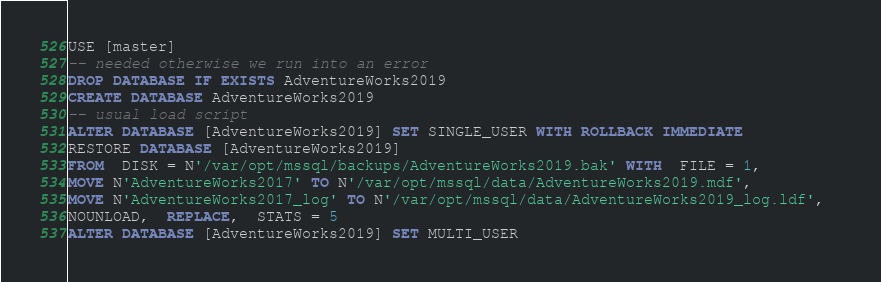Convert code to text. <code><loc_0><loc_0><loc_500><loc_500><_SQL_>USE [master]
-- needed otherwise we run into an error
DROP DATABASE IF EXISTS AdventureWorks2019
CREATE DATABASE AdventureWorks2019
-- usual load script
ALTER DATABASE [AdventureWorks2019] SET SINGLE_USER WITH ROLLBACK IMMEDIATE
RESTORE DATABASE [AdventureWorks2019] 
FROM  DISK = N'/var/opt/mssql/backups/AdventureWorks2019.bak' WITH  FILE = 1,  
MOVE N'AdventureWorks2017' TO N'/var/opt/mssql/data/AdventureWorks2019.mdf',  
MOVE N'AdventureWorks2017_log' TO N'/var/opt/mssql/data/AdventureWorks2019_log.ldf',  
NOUNLOAD,  REPLACE,  STATS = 5
ALTER DATABASE [AdventureWorks2019] SET MULTI_USER
</code> 